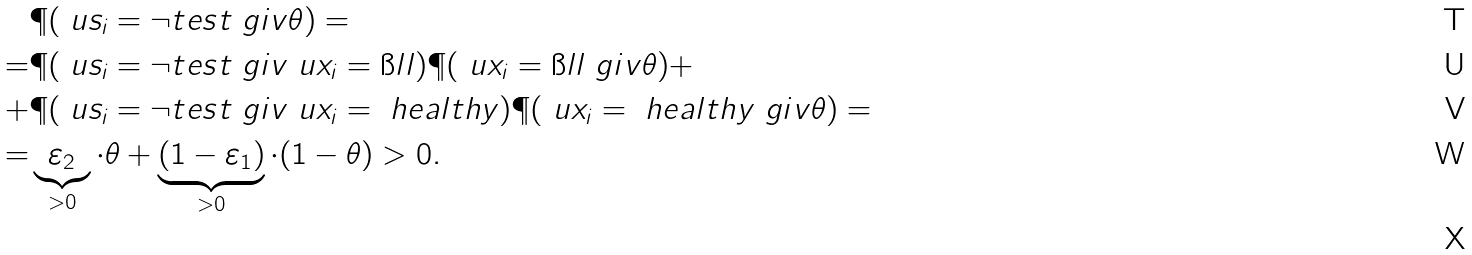Convert formula to latex. <formula><loc_0><loc_0><loc_500><loc_500>& \P ( \ u s _ { i } = \neg t e s t \ g i v \theta ) = \\ = & \P ( \ u s _ { i } = \neg t e s t \ g i v \ u x _ { i } = \i l l ) \P ( \ u x _ { i } = \i l l \ g i v \theta ) + \\ + & \P ( \ u s _ { i } = \neg t e s t \ g i v \ u x _ { i } = \ h e a l t h y ) \P ( \ u x _ { i } = \ h e a l t h y \ g i v \theta ) = \\ = & \underbrace { \varepsilon _ { 2 } } _ { > 0 } \cdot \theta + \underbrace { ( 1 - \varepsilon _ { 1 } ) } _ { > 0 } \cdot ( 1 - \theta ) > 0 . \\</formula> 